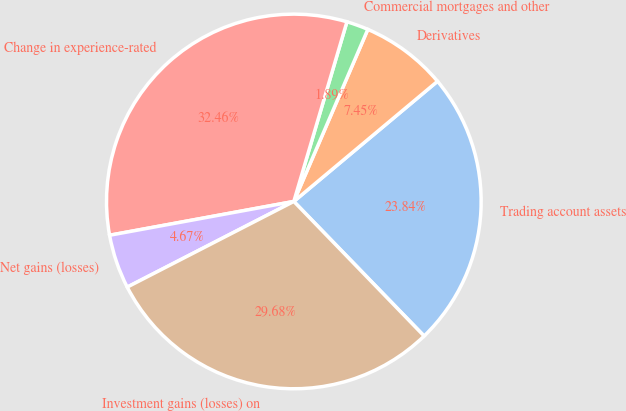Convert chart to OTSL. <chart><loc_0><loc_0><loc_500><loc_500><pie_chart><fcel>Trading account assets<fcel>Derivatives<fcel>Commercial mortgages and other<fcel>Change in experience-rated<fcel>Net gains (losses)<fcel>Investment gains (losses) on<nl><fcel>23.84%<fcel>7.45%<fcel>1.89%<fcel>32.46%<fcel>4.67%<fcel>29.68%<nl></chart> 